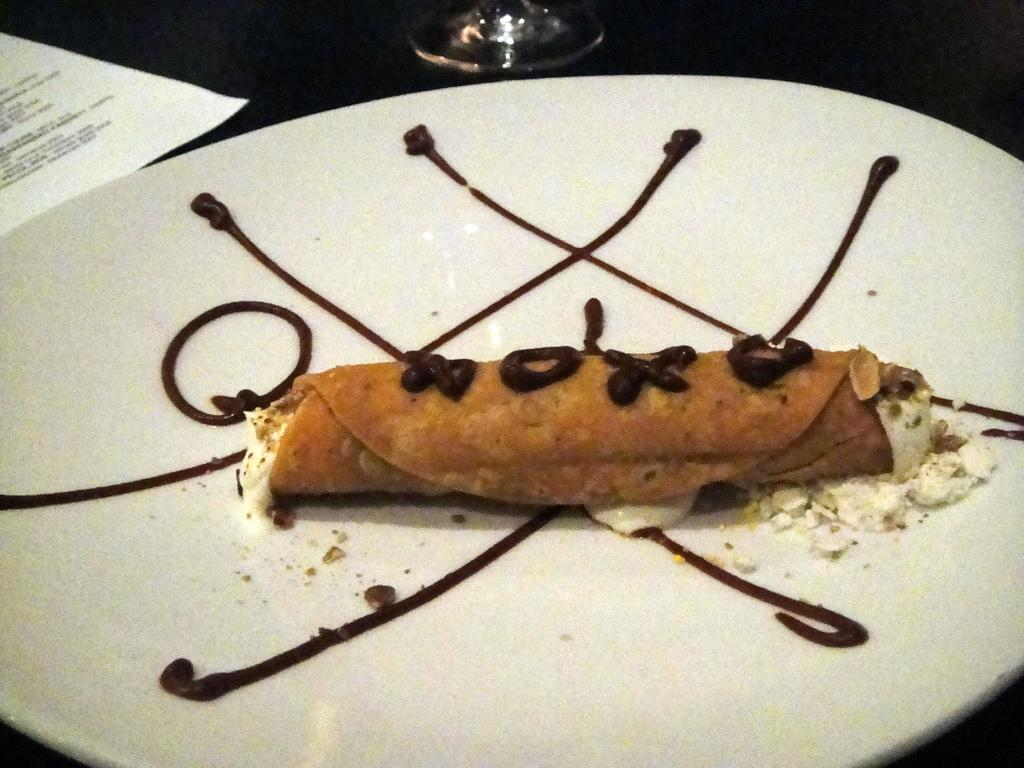What is on the plate that is visible in the image? There is food on a plate in the image. Where is the plate located in the image? The plate is on a table in the image. What is on the left side of the image? There is a paper on the left side of the image. What is in the front of the image? There is a glass in the front of the image. What direction is the bat flying in the image? There is no bat present in the image. 